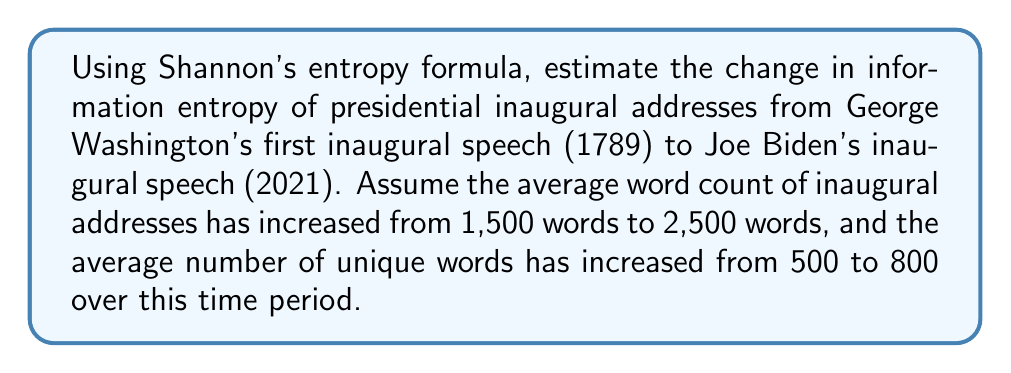What is the answer to this math problem? To solve this problem, we'll use Shannon's entropy formula and follow these steps:

1. Recall Shannon's entropy formula:
   $$H = -\sum_{i=1}^{n} p_i \log_2(p_i)$$
   where $H$ is the entropy, $p_i$ is the probability of each unique word.

2. For simplicity, we'll assume uniform distribution of unique words. So, $p_i = \frac{1}{\text{number of unique words}}$

3. For Washington's speech (1789):
   - Total words: 1,500
   - Unique words: 500
   - $p_i = \frac{1}{500}$
   
   $$H_{1789} = -500 \cdot \frac{1}{500} \log_2(\frac{1}{500}) = \log_2(500) \approx 8.97 \text{ bits}$$

4. For Biden's speech (2021):
   - Total words: 2,500
   - Unique words: 800
   - $p_i = \frac{1}{800}$
   
   $$H_{2021} = -800 \cdot \frac{1}{800} \log_2(\frac{1}{800}) = \log_2(800) \approx 9.64 \text{ bits}$$

5. Calculate the change in entropy:
   $$\Delta H = H_{2021} - H_{1789} = 9.64 - 8.97 = 0.67 \text{ bits}$$

This increase in entropy suggests that modern inaugural addresses contain more information and are potentially more complex or diverse in their word usage compared to early addresses.
Answer: 0.67 bits 